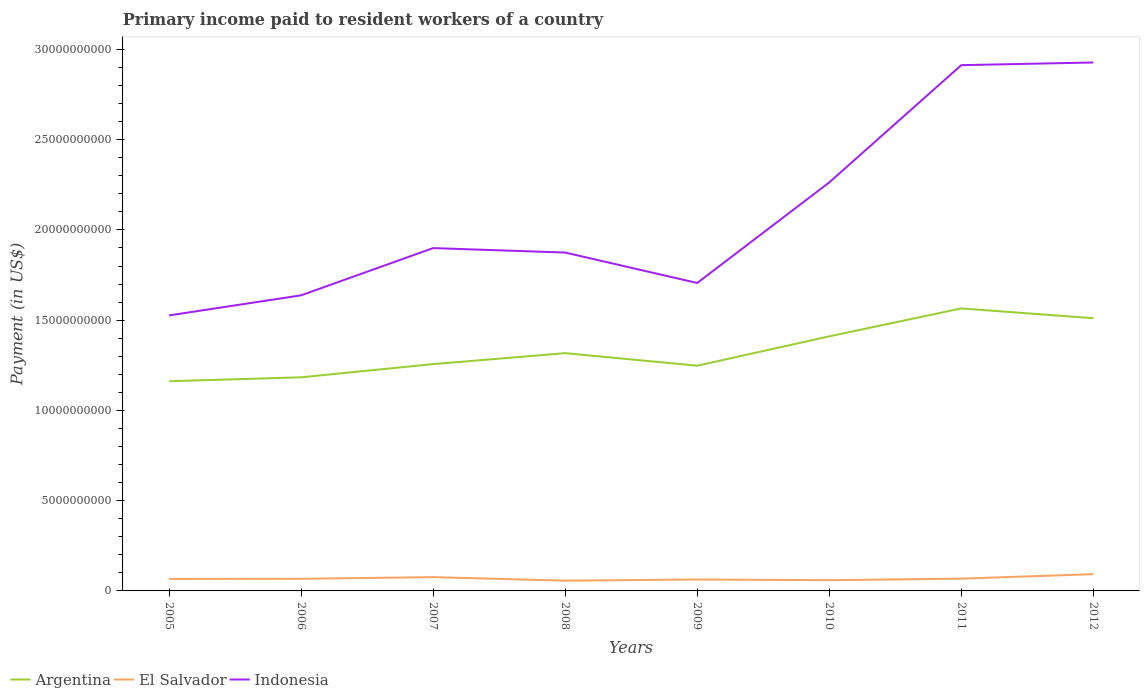How many different coloured lines are there?
Provide a succinct answer. 3. Does the line corresponding to El Salvador intersect with the line corresponding to Indonesia?
Your answer should be compact. No. Is the number of lines equal to the number of legend labels?
Your answer should be very brief. Yes. Across all years, what is the maximum amount paid to workers in El Salvador?
Your answer should be very brief. 5.68e+08. What is the total amount paid to workers in Indonesia in the graph?
Provide a succinct answer. -1.39e+1. What is the difference between the highest and the second highest amount paid to workers in Argentina?
Your answer should be compact. 4.03e+09. What is the difference between the highest and the lowest amount paid to workers in Argentina?
Provide a short and direct response. 3. How many lines are there?
Keep it short and to the point. 3. How many years are there in the graph?
Offer a terse response. 8. What is the difference between two consecutive major ticks on the Y-axis?
Make the answer very short. 5.00e+09. Are the values on the major ticks of Y-axis written in scientific E-notation?
Your answer should be compact. No. Does the graph contain grids?
Your response must be concise. No. Where does the legend appear in the graph?
Give a very brief answer. Bottom left. What is the title of the graph?
Provide a short and direct response. Primary income paid to resident workers of a country. What is the label or title of the Y-axis?
Give a very brief answer. Payment (in US$). What is the Payment (in US$) of Argentina in 2005?
Make the answer very short. 1.16e+1. What is the Payment (in US$) in El Salvador in 2005?
Your answer should be very brief. 6.65e+08. What is the Payment (in US$) of Indonesia in 2005?
Ensure brevity in your answer.  1.53e+1. What is the Payment (in US$) in Argentina in 2006?
Provide a short and direct response. 1.18e+1. What is the Payment (in US$) of El Salvador in 2006?
Keep it short and to the point. 6.72e+08. What is the Payment (in US$) of Indonesia in 2006?
Offer a terse response. 1.64e+1. What is the Payment (in US$) in Argentina in 2007?
Keep it short and to the point. 1.26e+1. What is the Payment (in US$) in El Salvador in 2007?
Your answer should be very brief. 7.64e+08. What is the Payment (in US$) in Indonesia in 2007?
Your answer should be very brief. 1.90e+1. What is the Payment (in US$) in Argentina in 2008?
Your response must be concise. 1.32e+1. What is the Payment (in US$) in El Salvador in 2008?
Your response must be concise. 5.68e+08. What is the Payment (in US$) in Indonesia in 2008?
Offer a terse response. 1.87e+1. What is the Payment (in US$) of Argentina in 2009?
Offer a very short reply. 1.25e+1. What is the Payment (in US$) of El Salvador in 2009?
Give a very brief answer. 6.33e+08. What is the Payment (in US$) of Indonesia in 2009?
Your response must be concise. 1.71e+1. What is the Payment (in US$) in Argentina in 2010?
Your answer should be compact. 1.41e+1. What is the Payment (in US$) in El Salvador in 2010?
Provide a short and direct response. 5.95e+08. What is the Payment (in US$) in Indonesia in 2010?
Offer a terse response. 2.26e+1. What is the Payment (in US$) in Argentina in 2011?
Your answer should be compact. 1.57e+1. What is the Payment (in US$) of El Salvador in 2011?
Make the answer very short. 6.80e+08. What is the Payment (in US$) in Indonesia in 2011?
Provide a succinct answer. 2.91e+1. What is the Payment (in US$) of Argentina in 2012?
Offer a terse response. 1.51e+1. What is the Payment (in US$) in El Salvador in 2012?
Your answer should be very brief. 9.29e+08. What is the Payment (in US$) in Indonesia in 2012?
Make the answer very short. 2.93e+1. Across all years, what is the maximum Payment (in US$) of Argentina?
Give a very brief answer. 1.57e+1. Across all years, what is the maximum Payment (in US$) in El Salvador?
Offer a very short reply. 9.29e+08. Across all years, what is the maximum Payment (in US$) in Indonesia?
Your answer should be compact. 2.93e+1. Across all years, what is the minimum Payment (in US$) in Argentina?
Your response must be concise. 1.16e+1. Across all years, what is the minimum Payment (in US$) in El Salvador?
Your answer should be compact. 5.68e+08. Across all years, what is the minimum Payment (in US$) in Indonesia?
Give a very brief answer. 1.53e+1. What is the total Payment (in US$) in Argentina in the graph?
Provide a succinct answer. 1.07e+11. What is the total Payment (in US$) of El Salvador in the graph?
Your answer should be compact. 5.51e+09. What is the total Payment (in US$) in Indonesia in the graph?
Offer a terse response. 1.67e+11. What is the difference between the Payment (in US$) of Argentina in 2005 and that in 2006?
Offer a very short reply. -2.18e+08. What is the difference between the Payment (in US$) in El Salvador in 2005 and that in 2006?
Give a very brief answer. -6.92e+06. What is the difference between the Payment (in US$) in Indonesia in 2005 and that in 2006?
Provide a short and direct response. -1.11e+09. What is the difference between the Payment (in US$) in Argentina in 2005 and that in 2007?
Keep it short and to the point. -9.50e+08. What is the difference between the Payment (in US$) in El Salvador in 2005 and that in 2007?
Offer a very short reply. -9.93e+07. What is the difference between the Payment (in US$) of Indonesia in 2005 and that in 2007?
Your answer should be compact. -3.73e+09. What is the difference between the Payment (in US$) in Argentina in 2005 and that in 2008?
Provide a short and direct response. -1.56e+09. What is the difference between the Payment (in US$) of El Salvador in 2005 and that in 2008?
Provide a succinct answer. 9.67e+07. What is the difference between the Payment (in US$) in Indonesia in 2005 and that in 2008?
Give a very brief answer. -3.48e+09. What is the difference between the Payment (in US$) in Argentina in 2005 and that in 2009?
Provide a succinct answer. -8.62e+08. What is the difference between the Payment (in US$) in El Salvador in 2005 and that in 2009?
Provide a short and direct response. 3.21e+07. What is the difference between the Payment (in US$) of Indonesia in 2005 and that in 2009?
Offer a very short reply. -1.80e+09. What is the difference between the Payment (in US$) of Argentina in 2005 and that in 2010?
Give a very brief answer. -2.49e+09. What is the difference between the Payment (in US$) in El Salvador in 2005 and that in 2010?
Provide a short and direct response. 7.03e+07. What is the difference between the Payment (in US$) in Indonesia in 2005 and that in 2010?
Ensure brevity in your answer.  -7.37e+09. What is the difference between the Payment (in US$) in Argentina in 2005 and that in 2011?
Ensure brevity in your answer.  -4.03e+09. What is the difference between the Payment (in US$) of El Salvador in 2005 and that in 2011?
Give a very brief answer. -1.49e+07. What is the difference between the Payment (in US$) in Indonesia in 2005 and that in 2011?
Make the answer very short. -1.39e+1. What is the difference between the Payment (in US$) in Argentina in 2005 and that in 2012?
Offer a terse response. -3.49e+09. What is the difference between the Payment (in US$) in El Salvador in 2005 and that in 2012?
Your answer should be compact. -2.64e+08. What is the difference between the Payment (in US$) in Indonesia in 2005 and that in 2012?
Offer a terse response. -1.40e+1. What is the difference between the Payment (in US$) of Argentina in 2006 and that in 2007?
Make the answer very short. -7.31e+08. What is the difference between the Payment (in US$) in El Salvador in 2006 and that in 2007?
Keep it short and to the point. -9.24e+07. What is the difference between the Payment (in US$) in Indonesia in 2006 and that in 2007?
Your answer should be very brief. -2.62e+09. What is the difference between the Payment (in US$) in Argentina in 2006 and that in 2008?
Ensure brevity in your answer.  -1.34e+09. What is the difference between the Payment (in US$) in El Salvador in 2006 and that in 2008?
Make the answer very short. 1.04e+08. What is the difference between the Payment (in US$) in Indonesia in 2006 and that in 2008?
Keep it short and to the point. -2.37e+09. What is the difference between the Payment (in US$) of Argentina in 2006 and that in 2009?
Provide a succinct answer. -6.43e+08. What is the difference between the Payment (in US$) in El Salvador in 2006 and that in 2009?
Ensure brevity in your answer.  3.90e+07. What is the difference between the Payment (in US$) of Indonesia in 2006 and that in 2009?
Offer a terse response. -6.84e+08. What is the difference between the Payment (in US$) in Argentina in 2006 and that in 2010?
Your response must be concise. -2.27e+09. What is the difference between the Payment (in US$) of El Salvador in 2006 and that in 2010?
Ensure brevity in your answer.  7.72e+07. What is the difference between the Payment (in US$) in Indonesia in 2006 and that in 2010?
Make the answer very short. -6.26e+09. What is the difference between the Payment (in US$) in Argentina in 2006 and that in 2011?
Provide a succinct answer. -3.82e+09. What is the difference between the Payment (in US$) in El Salvador in 2006 and that in 2011?
Your response must be concise. -8.01e+06. What is the difference between the Payment (in US$) in Indonesia in 2006 and that in 2011?
Offer a very short reply. -1.28e+1. What is the difference between the Payment (in US$) in Argentina in 2006 and that in 2012?
Ensure brevity in your answer.  -3.27e+09. What is the difference between the Payment (in US$) of El Salvador in 2006 and that in 2012?
Offer a very short reply. -2.57e+08. What is the difference between the Payment (in US$) in Indonesia in 2006 and that in 2012?
Make the answer very short. -1.29e+1. What is the difference between the Payment (in US$) in Argentina in 2007 and that in 2008?
Make the answer very short. -6.06e+08. What is the difference between the Payment (in US$) in El Salvador in 2007 and that in 2008?
Offer a very short reply. 1.96e+08. What is the difference between the Payment (in US$) of Indonesia in 2007 and that in 2008?
Your response must be concise. 2.47e+08. What is the difference between the Payment (in US$) of Argentina in 2007 and that in 2009?
Provide a succinct answer. 8.81e+07. What is the difference between the Payment (in US$) in El Salvador in 2007 and that in 2009?
Your answer should be very brief. 1.31e+08. What is the difference between the Payment (in US$) in Indonesia in 2007 and that in 2009?
Offer a terse response. 1.93e+09. What is the difference between the Payment (in US$) in Argentina in 2007 and that in 2010?
Your answer should be very brief. -1.54e+09. What is the difference between the Payment (in US$) in El Salvador in 2007 and that in 2010?
Provide a succinct answer. 1.70e+08. What is the difference between the Payment (in US$) in Indonesia in 2007 and that in 2010?
Your answer should be compact. -3.64e+09. What is the difference between the Payment (in US$) in Argentina in 2007 and that in 2011?
Keep it short and to the point. -3.08e+09. What is the difference between the Payment (in US$) of El Salvador in 2007 and that in 2011?
Give a very brief answer. 8.43e+07. What is the difference between the Payment (in US$) of Indonesia in 2007 and that in 2011?
Make the answer very short. -1.01e+1. What is the difference between the Payment (in US$) in Argentina in 2007 and that in 2012?
Give a very brief answer. -2.54e+09. What is the difference between the Payment (in US$) in El Salvador in 2007 and that in 2012?
Your response must be concise. -1.65e+08. What is the difference between the Payment (in US$) in Indonesia in 2007 and that in 2012?
Offer a very short reply. -1.03e+1. What is the difference between the Payment (in US$) in Argentina in 2008 and that in 2009?
Make the answer very short. 6.94e+08. What is the difference between the Payment (in US$) of El Salvador in 2008 and that in 2009?
Offer a terse response. -6.46e+07. What is the difference between the Payment (in US$) in Indonesia in 2008 and that in 2009?
Your answer should be compact. 1.69e+09. What is the difference between the Payment (in US$) of Argentina in 2008 and that in 2010?
Provide a short and direct response. -9.32e+08. What is the difference between the Payment (in US$) in El Salvador in 2008 and that in 2010?
Your answer should be very brief. -2.64e+07. What is the difference between the Payment (in US$) of Indonesia in 2008 and that in 2010?
Offer a very short reply. -3.88e+09. What is the difference between the Payment (in US$) of Argentina in 2008 and that in 2011?
Give a very brief answer. -2.48e+09. What is the difference between the Payment (in US$) in El Salvador in 2008 and that in 2011?
Your answer should be very brief. -1.12e+08. What is the difference between the Payment (in US$) in Indonesia in 2008 and that in 2011?
Your response must be concise. -1.04e+1. What is the difference between the Payment (in US$) of Argentina in 2008 and that in 2012?
Provide a short and direct response. -1.94e+09. What is the difference between the Payment (in US$) in El Salvador in 2008 and that in 2012?
Your response must be concise. -3.61e+08. What is the difference between the Payment (in US$) of Indonesia in 2008 and that in 2012?
Give a very brief answer. -1.05e+1. What is the difference between the Payment (in US$) of Argentina in 2009 and that in 2010?
Make the answer very short. -1.63e+09. What is the difference between the Payment (in US$) in El Salvador in 2009 and that in 2010?
Provide a short and direct response. 3.82e+07. What is the difference between the Payment (in US$) in Indonesia in 2009 and that in 2010?
Your answer should be compact. -5.57e+09. What is the difference between the Payment (in US$) in Argentina in 2009 and that in 2011?
Make the answer very short. -3.17e+09. What is the difference between the Payment (in US$) of El Salvador in 2009 and that in 2011?
Make the answer very short. -4.70e+07. What is the difference between the Payment (in US$) in Indonesia in 2009 and that in 2011?
Ensure brevity in your answer.  -1.21e+1. What is the difference between the Payment (in US$) of Argentina in 2009 and that in 2012?
Provide a short and direct response. -2.63e+09. What is the difference between the Payment (in US$) in El Salvador in 2009 and that in 2012?
Give a very brief answer. -2.96e+08. What is the difference between the Payment (in US$) in Indonesia in 2009 and that in 2012?
Your answer should be compact. -1.22e+1. What is the difference between the Payment (in US$) of Argentina in 2010 and that in 2011?
Offer a terse response. -1.55e+09. What is the difference between the Payment (in US$) of El Salvador in 2010 and that in 2011?
Offer a very short reply. -8.52e+07. What is the difference between the Payment (in US$) of Indonesia in 2010 and that in 2011?
Offer a very short reply. -6.50e+09. What is the difference between the Payment (in US$) of Argentina in 2010 and that in 2012?
Keep it short and to the point. -1.01e+09. What is the difference between the Payment (in US$) in El Salvador in 2010 and that in 2012?
Offer a terse response. -3.34e+08. What is the difference between the Payment (in US$) of Indonesia in 2010 and that in 2012?
Offer a very short reply. -6.65e+09. What is the difference between the Payment (in US$) in Argentina in 2011 and that in 2012?
Offer a very short reply. 5.42e+08. What is the difference between the Payment (in US$) in El Salvador in 2011 and that in 2012?
Your answer should be compact. -2.49e+08. What is the difference between the Payment (in US$) in Indonesia in 2011 and that in 2012?
Your answer should be compact. -1.49e+08. What is the difference between the Payment (in US$) in Argentina in 2005 and the Payment (in US$) in El Salvador in 2006?
Your answer should be very brief. 1.09e+1. What is the difference between the Payment (in US$) in Argentina in 2005 and the Payment (in US$) in Indonesia in 2006?
Your response must be concise. -4.76e+09. What is the difference between the Payment (in US$) in El Salvador in 2005 and the Payment (in US$) in Indonesia in 2006?
Keep it short and to the point. -1.57e+1. What is the difference between the Payment (in US$) of Argentina in 2005 and the Payment (in US$) of El Salvador in 2007?
Keep it short and to the point. 1.09e+1. What is the difference between the Payment (in US$) in Argentina in 2005 and the Payment (in US$) in Indonesia in 2007?
Provide a succinct answer. -7.38e+09. What is the difference between the Payment (in US$) in El Salvador in 2005 and the Payment (in US$) in Indonesia in 2007?
Keep it short and to the point. -1.83e+1. What is the difference between the Payment (in US$) of Argentina in 2005 and the Payment (in US$) of El Salvador in 2008?
Provide a short and direct response. 1.10e+1. What is the difference between the Payment (in US$) in Argentina in 2005 and the Payment (in US$) in Indonesia in 2008?
Give a very brief answer. -7.13e+09. What is the difference between the Payment (in US$) of El Salvador in 2005 and the Payment (in US$) of Indonesia in 2008?
Provide a succinct answer. -1.81e+1. What is the difference between the Payment (in US$) of Argentina in 2005 and the Payment (in US$) of El Salvador in 2009?
Provide a succinct answer. 1.10e+1. What is the difference between the Payment (in US$) of Argentina in 2005 and the Payment (in US$) of Indonesia in 2009?
Offer a very short reply. -5.44e+09. What is the difference between the Payment (in US$) in El Salvador in 2005 and the Payment (in US$) in Indonesia in 2009?
Provide a short and direct response. -1.64e+1. What is the difference between the Payment (in US$) of Argentina in 2005 and the Payment (in US$) of El Salvador in 2010?
Give a very brief answer. 1.10e+1. What is the difference between the Payment (in US$) in Argentina in 2005 and the Payment (in US$) in Indonesia in 2010?
Your answer should be compact. -1.10e+1. What is the difference between the Payment (in US$) of El Salvador in 2005 and the Payment (in US$) of Indonesia in 2010?
Give a very brief answer. -2.20e+1. What is the difference between the Payment (in US$) in Argentina in 2005 and the Payment (in US$) in El Salvador in 2011?
Provide a short and direct response. 1.09e+1. What is the difference between the Payment (in US$) of Argentina in 2005 and the Payment (in US$) of Indonesia in 2011?
Ensure brevity in your answer.  -1.75e+1. What is the difference between the Payment (in US$) in El Salvador in 2005 and the Payment (in US$) in Indonesia in 2011?
Provide a succinct answer. -2.85e+1. What is the difference between the Payment (in US$) of Argentina in 2005 and the Payment (in US$) of El Salvador in 2012?
Give a very brief answer. 1.07e+1. What is the difference between the Payment (in US$) of Argentina in 2005 and the Payment (in US$) of Indonesia in 2012?
Offer a very short reply. -1.77e+1. What is the difference between the Payment (in US$) in El Salvador in 2005 and the Payment (in US$) in Indonesia in 2012?
Provide a succinct answer. -2.86e+1. What is the difference between the Payment (in US$) in Argentina in 2006 and the Payment (in US$) in El Salvador in 2007?
Offer a terse response. 1.11e+1. What is the difference between the Payment (in US$) in Argentina in 2006 and the Payment (in US$) in Indonesia in 2007?
Offer a terse response. -7.16e+09. What is the difference between the Payment (in US$) of El Salvador in 2006 and the Payment (in US$) of Indonesia in 2007?
Your answer should be very brief. -1.83e+1. What is the difference between the Payment (in US$) of Argentina in 2006 and the Payment (in US$) of El Salvador in 2008?
Give a very brief answer. 1.13e+1. What is the difference between the Payment (in US$) in Argentina in 2006 and the Payment (in US$) in Indonesia in 2008?
Provide a short and direct response. -6.91e+09. What is the difference between the Payment (in US$) of El Salvador in 2006 and the Payment (in US$) of Indonesia in 2008?
Keep it short and to the point. -1.81e+1. What is the difference between the Payment (in US$) of Argentina in 2006 and the Payment (in US$) of El Salvador in 2009?
Your answer should be compact. 1.12e+1. What is the difference between the Payment (in US$) in Argentina in 2006 and the Payment (in US$) in Indonesia in 2009?
Ensure brevity in your answer.  -5.23e+09. What is the difference between the Payment (in US$) in El Salvador in 2006 and the Payment (in US$) in Indonesia in 2009?
Offer a terse response. -1.64e+1. What is the difference between the Payment (in US$) in Argentina in 2006 and the Payment (in US$) in El Salvador in 2010?
Provide a short and direct response. 1.12e+1. What is the difference between the Payment (in US$) of Argentina in 2006 and the Payment (in US$) of Indonesia in 2010?
Offer a very short reply. -1.08e+1. What is the difference between the Payment (in US$) in El Salvador in 2006 and the Payment (in US$) in Indonesia in 2010?
Give a very brief answer. -2.20e+1. What is the difference between the Payment (in US$) of Argentina in 2006 and the Payment (in US$) of El Salvador in 2011?
Your answer should be compact. 1.12e+1. What is the difference between the Payment (in US$) in Argentina in 2006 and the Payment (in US$) in Indonesia in 2011?
Provide a short and direct response. -1.73e+1. What is the difference between the Payment (in US$) in El Salvador in 2006 and the Payment (in US$) in Indonesia in 2011?
Offer a terse response. -2.85e+1. What is the difference between the Payment (in US$) of Argentina in 2006 and the Payment (in US$) of El Salvador in 2012?
Offer a terse response. 1.09e+1. What is the difference between the Payment (in US$) in Argentina in 2006 and the Payment (in US$) in Indonesia in 2012?
Your answer should be compact. -1.74e+1. What is the difference between the Payment (in US$) in El Salvador in 2006 and the Payment (in US$) in Indonesia in 2012?
Offer a terse response. -2.86e+1. What is the difference between the Payment (in US$) of Argentina in 2007 and the Payment (in US$) of El Salvador in 2008?
Keep it short and to the point. 1.20e+1. What is the difference between the Payment (in US$) of Argentina in 2007 and the Payment (in US$) of Indonesia in 2008?
Provide a succinct answer. -6.18e+09. What is the difference between the Payment (in US$) in El Salvador in 2007 and the Payment (in US$) in Indonesia in 2008?
Provide a succinct answer. -1.80e+1. What is the difference between the Payment (in US$) of Argentina in 2007 and the Payment (in US$) of El Salvador in 2009?
Make the answer very short. 1.19e+1. What is the difference between the Payment (in US$) in Argentina in 2007 and the Payment (in US$) in Indonesia in 2009?
Your response must be concise. -4.49e+09. What is the difference between the Payment (in US$) in El Salvador in 2007 and the Payment (in US$) in Indonesia in 2009?
Your answer should be compact. -1.63e+1. What is the difference between the Payment (in US$) in Argentina in 2007 and the Payment (in US$) in El Salvador in 2010?
Your response must be concise. 1.20e+1. What is the difference between the Payment (in US$) in Argentina in 2007 and the Payment (in US$) in Indonesia in 2010?
Offer a terse response. -1.01e+1. What is the difference between the Payment (in US$) of El Salvador in 2007 and the Payment (in US$) of Indonesia in 2010?
Make the answer very short. -2.19e+1. What is the difference between the Payment (in US$) of Argentina in 2007 and the Payment (in US$) of El Salvador in 2011?
Your answer should be compact. 1.19e+1. What is the difference between the Payment (in US$) of Argentina in 2007 and the Payment (in US$) of Indonesia in 2011?
Your answer should be very brief. -1.66e+1. What is the difference between the Payment (in US$) in El Salvador in 2007 and the Payment (in US$) in Indonesia in 2011?
Your answer should be very brief. -2.84e+1. What is the difference between the Payment (in US$) in Argentina in 2007 and the Payment (in US$) in El Salvador in 2012?
Your answer should be very brief. 1.16e+1. What is the difference between the Payment (in US$) in Argentina in 2007 and the Payment (in US$) in Indonesia in 2012?
Your answer should be compact. -1.67e+1. What is the difference between the Payment (in US$) in El Salvador in 2007 and the Payment (in US$) in Indonesia in 2012?
Offer a very short reply. -2.85e+1. What is the difference between the Payment (in US$) of Argentina in 2008 and the Payment (in US$) of El Salvador in 2009?
Your answer should be compact. 1.25e+1. What is the difference between the Payment (in US$) of Argentina in 2008 and the Payment (in US$) of Indonesia in 2009?
Provide a short and direct response. -3.89e+09. What is the difference between the Payment (in US$) of El Salvador in 2008 and the Payment (in US$) of Indonesia in 2009?
Your response must be concise. -1.65e+1. What is the difference between the Payment (in US$) of Argentina in 2008 and the Payment (in US$) of El Salvador in 2010?
Ensure brevity in your answer.  1.26e+1. What is the difference between the Payment (in US$) in Argentina in 2008 and the Payment (in US$) in Indonesia in 2010?
Your answer should be compact. -9.46e+09. What is the difference between the Payment (in US$) in El Salvador in 2008 and the Payment (in US$) in Indonesia in 2010?
Give a very brief answer. -2.21e+1. What is the difference between the Payment (in US$) in Argentina in 2008 and the Payment (in US$) in El Salvador in 2011?
Offer a terse response. 1.25e+1. What is the difference between the Payment (in US$) in Argentina in 2008 and the Payment (in US$) in Indonesia in 2011?
Ensure brevity in your answer.  -1.60e+1. What is the difference between the Payment (in US$) in El Salvador in 2008 and the Payment (in US$) in Indonesia in 2011?
Your answer should be very brief. -2.86e+1. What is the difference between the Payment (in US$) of Argentina in 2008 and the Payment (in US$) of El Salvador in 2012?
Your response must be concise. 1.22e+1. What is the difference between the Payment (in US$) of Argentina in 2008 and the Payment (in US$) of Indonesia in 2012?
Provide a short and direct response. -1.61e+1. What is the difference between the Payment (in US$) in El Salvador in 2008 and the Payment (in US$) in Indonesia in 2012?
Keep it short and to the point. -2.87e+1. What is the difference between the Payment (in US$) in Argentina in 2009 and the Payment (in US$) in El Salvador in 2010?
Offer a very short reply. 1.19e+1. What is the difference between the Payment (in US$) of Argentina in 2009 and the Payment (in US$) of Indonesia in 2010?
Give a very brief answer. -1.02e+1. What is the difference between the Payment (in US$) of El Salvador in 2009 and the Payment (in US$) of Indonesia in 2010?
Provide a short and direct response. -2.20e+1. What is the difference between the Payment (in US$) of Argentina in 2009 and the Payment (in US$) of El Salvador in 2011?
Ensure brevity in your answer.  1.18e+1. What is the difference between the Payment (in US$) of Argentina in 2009 and the Payment (in US$) of Indonesia in 2011?
Your answer should be compact. -1.66e+1. What is the difference between the Payment (in US$) of El Salvador in 2009 and the Payment (in US$) of Indonesia in 2011?
Keep it short and to the point. -2.85e+1. What is the difference between the Payment (in US$) of Argentina in 2009 and the Payment (in US$) of El Salvador in 2012?
Your answer should be very brief. 1.15e+1. What is the difference between the Payment (in US$) in Argentina in 2009 and the Payment (in US$) in Indonesia in 2012?
Offer a very short reply. -1.68e+1. What is the difference between the Payment (in US$) in El Salvador in 2009 and the Payment (in US$) in Indonesia in 2012?
Keep it short and to the point. -2.86e+1. What is the difference between the Payment (in US$) in Argentina in 2010 and the Payment (in US$) in El Salvador in 2011?
Make the answer very short. 1.34e+1. What is the difference between the Payment (in US$) in Argentina in 2010 and the Payment (in US$) in Indonesia in 2011?
Your answer should be compact. -1.50e+1. What is the difference between the Payment (in US$) of El Salvador in 2010 and the Payment (in US$) of Indonesia in 2011?
Keep it short and to the point. -2.85e+1. What is the difference between the Payment (in US$) of Argentina in 2010 and the Payment (in US$) of El Salvador in 2012?
Offer a very short reply. 1.32e+1. What is the difference between the Payment (in US$) in Argentina in 2010 and the Payment (in US$) in Indonesia in 2012?
Provide a succinct answer. -1.52e+1. What is the difference between the Payment (in US$) of El Salvador in 2010 and the Payment (in US$) of Indonesia in 2012?
Keep it short and to the point. -2.87e+1. What is the difference between the Payment (in US$) of Argentina in 2011 and the Payment (in US$) of El Salvador in 2012?
Your response must be concise. 1.47e+1. What is the difference between the Payment (in US$) in Argentina in 2011 and the Payment (in US$) in Indonesia in 2012?
Provide a succinct answer. -1.36e+1. What is the difference between the Payment (in US$) in El Salvador in 2011 and the Payment (in US$) in Indonesia in 2012?
Your answer should be compact. -2.86e+1. What is the average Payment (in US$) of Argentina per year?
Offer a very short reply. 1.33e+1. What is the average Payment (in US$) in El Salvador per year?
Your answer should be compact. 6.88e+08. What is the average Payment (in US$) in Indonesia per year?
Offer a terse response. 2.09e+1. In the year 2005, what is the difference between the Payment (in US$) of Argentina and Payment (in US$) of El Salvador?
Give a very brief answer. 1.10e+1. In the year 2005, what is the difference between the Payment (in US$) of Argentina and Payment (in US$) of Indonesia?
Offer a very short reply. -3.65e+09. In the year 2005, what is the difference between the Payment (in US$) of El Salvador and Payment (in US$) of Indonesia?
Offer a terse response. -1.46e+1. In the year 2006, what is the difference between the Payment (in US$) of Argentina and Payment (in US$) of El Salvador?
Keep it short and to the point. 1.12e+1. In the year 2006, what is the difference between the Payment (in US$) of Argentina and Payment (in US$) of Indonesia?
Provide a succinct answer. -4.54e+09. In the year 2006, what is the difference between the Payment (in US$) of El Salvador and Payment (in US$) of Indonesia?
Provide a succinct answer. -1.57e+1. In the year 2007, what is the difference between the Payment (in US$) of Argentina and Payment (in US$) of El Salvador?
Ensure brevity in your answer.  1.18e+1. In the year 2007, what is the difference between the Payment (in US$) in Argentina and Payment (in US$) in Indonesia?
Provide a succinct answer. -6.43e+09. In the year 2007, what is the difference between the Payment (in US$) in El Salvador and Payment (in US$) in Indonesia?
Your response must be concise. -1.82e+1. In the year 2008, what is the difference between the Payment (in US$) of Argentina and Payment (in US$) of El Salvador?
Provide a short and direct response. 1.26e+1. In the year 2008, what is the difference between the Payment (in US$) in Argentina and Payment (in US$) in Indonesia?
Your answer should be compact. -5.57e+09. In the year 2008, what is the difference between the Payment (in US$) in El Salvador and Payment (in US$) in Indonesia?
Your answer should be compact. -1.82e+1. In the year 2009, what is the difference between the Payment (in US$) of Argentina and Payment (in US$) of El Salvador?
Ensure brevity in your answer.  1.18e+1. In the year 2009, what is the difference between the Payment (in US$) of Argentina and Payment (in US$) of Indonesia?
Offer a terse response. -4.58e+09. In the year 2009, what is the difference between the Payment (in US$) in El Salvador and Payment (in US$) in Indonesia?
Offer a terse response. -1.64e+1. In the year 2010, what is the difference between the Payment (in US$) of Argentina and Payment (in US$) of El Salvador?
Ensure brevity in your answer.  1.35e+1. In the year 2010, what is the difference between the Payment (in US$) in Argentina and Payment (in US$) in Indonesia?
Your answer should be very brief. -8.53e+09. In the year 2010, what is the difference between the Payment (in US$) of El Salvador and Payment (in US$) of Indonesia?
Offer a terse response. -2.20e+1. In the year 2011, what is the difference between the Payment (in US$) in Argentina and Payment (in US$) in El Salvador?
Provide a succinct answer. 1.50e+1. In the year 2011, what is the difference between the Payment (in US$) in Argentina and Payment (in US$) in Indonesia?
Provide a short and direct response. -1.35e+1. In the year 2011, what is the difference between the Payment (in US$) in El Salvador and Payment (in US$) in Indonesia?
Your answer should be compact. -2.84e+1. In the year 2012, what is the difference between the Payment (in US$) of Argentina and Payment (in US$) of El Salvador?
Your answer should be compact. 1.42e+1. In the year 2012, what is the difference between the Payment (in US$) in Argentina and Payment (in US$) in Indonesia?
Give a very brief answer. -1.42e+1. In the year 2012, what is the difference between the Payment (in US$) of El Salvador and Payment (in US$) of Indonesia?
Keep it short and to the point. -2.83e+1. What is the ratio of the Payment (in US$) in Argentina in 2005 to that in 2006?
Keep it short and to the point. 0.98. What is the ratio of the Payment (in US$) in El Salvador in 2005 to that in 2006?
Provide a succinct answer. 0.99. What is the ratio of the Payment (in US$) of Indonesia in 2005 to that in 2006?
Give a very brief answer. 0.93. What is the ratio of the Payment (in US$) in Argentina in 2005 to that in 2007?
Provide a succinct answer. 0.92. What is the ratio of the Payment (in US$) in El Salvador in 2005 to that in 2007?
Your response must be concise. 0.87. What is the ratio of the Payment (in US$) in Indonesia in 2005 to that in 2007?
Offer a terse response. 0.8. What is the ratio of the Payment (in US$) in Argentina in 2005 to that in 2008?
Give a very brief answer. 0.88. What is the ratio of the Payment (in US$) of El Salvador in 2005 to that in 2008?
Ensure brevity in your answer.  1.17. What is the ratio of the Payment (in US$) in Indonesia in 2005 to that in 2008?
Offer a terse response. 0.81. What is the ratio of the Payment (in US$) of Argentina in 2005 to that in 2009?
Give a very brief answer. 0.93. What is the ratio of the Payment (in US$) of El Salvador in 2005 to that in 2009?
Provide a succinct answer. 1.05. What is the ratio of the Payment (in US$) of Indonesia in 2005 to that in 2009?
Ensure brevity in your answer.  0.89. What is the ratio of the Payment (in US$) in Argentina in 2005 to that in 2010?
Ensure brevity in your answer.  0.82. What is the ratio of the Payment (in US$) in El Salvador in 2005 to that in 2010?
Your answer should be compact. 1.12. What is the ratio of the Payment (in US$) of Indonesia in 2005 to that in 2010?
Provide a short and direct response. 0.67. What is the ratio of the Payment (in US$) of Argentina in 2005 to that in 2011?
Give a very brief answer. 0.74. What is the ratio of the Payment (in US$) of El Salvador in 2005 to that in 2011?
Keep it short and to the point. 0.98. What is the ratio of the Payment (in US$) of Indonesia in 2005 to that in 2011?
Give a very brief answer. 0.52. What is the ratio of the Payment (in US$) of Argentina in 2005 to that in 2012?
Offer a very short reply. 0.77. What is the ratio of the Payment (in US$) of El Salvador in 2005 to that in 2012?
Ensure brevity in your answer.  0.72. What is the ratio of the Payment (in US$) in Indonesia in 2005 to that in 2012?
Provide a succinct answer. 0.52. What is the ratio of the Payment (in US$) in Argentina in 2006 to that in 2007?
Offer a terse response. 0.94. What is the ratio of the Payment (in US$) of El Salvador in 2006 to that in 2007?
Offer a terse response. 0.88. What is the ratio of the Payment (in US$) in Indonesia in 2006 to that in 2007?
Make the answer very short. 0.86. What is the ratio of the Payment (in US$) in Argentina in 2006 to that in 2008?
Keep it short and to the point. 0.9. What is the ratio of the Payment (in US$) of El Salvador in 2006 to that in 2008?
Your answer should be very brief. 1.18. What is the ratio of the Payment (in US$) in Indonesia in 2006 to that in 2008?
Your answer should be compact. 0.87. What is the ratio of the Payment (in US$) in Argentina in 2006 to that in 2009?
Your response must be concise. 0.95. What is the ratio of the Payment (in US$) of El Salvador in 2006 to that in 2009?
Provide a short and direct response. 1.06. What is the ratio of the Payment (in US$) of Indonesia in 2006 to that in 2009?
Give a very brief answer. 0.96. What is the ratio of the Payment (in US$) in Argentina in 2006 to that in 2010?
Ensure brevity in your answer.  0.84. What is the ratio of the Payment (in US$) in El Salvador in 2006 to that in 2010?
Offer a very short reply. 1.13. What is the ratio of the Payment (in US$) of Indonesia in 2006 to that in 2010?
Make the answer very short. 0.72. What is the ratio of the Payment (in US$) in Argentina in 2006 to that in 2011?
Offer a very short reply. 0.76. What is the ratio of the Payment (in US$) of El Salvador in 2006 to that in 2011?
Your answer should be very brief. 0.99. What is the ratio of the Payment (in US$) in Indonesia in 2006 to that in 2011?
Provide a succinct answer. 0.56. What is the ratio of the Payment (in US$) in Argentina in 2006 to that in 2012?
Offer a very short reply. 0.78. What is the ratio of the Payment (in US$) in El Salvador in 2006 to that in 2012?
Ensure brevity in your answer.  0.72. What is the ratio of the Payment (in US$) of Indonesia in 2006 to that in 2012?
Give a very brief answer. 0.56. What is the ratio of the Payment (in US$) of Argentina in 2007 to that in 2008?
Your answer should be very brief. 0.95. What is the ratio of the Payment (in US$) of El Salvador in 2007 to that in 2008?
Provide a short and direct response. 1.34. What is the ratio of the Payment (in US$) in Indonesia in 2007 to that in 2008?
Offer a terse response. 1.01. What is the ratio of the Payment (in US$) in Argentina in 2007 to that in 2009?
Your answer should be very brief. 1.01. What is the ratio of the Payment (in US$) in El Salvador in 2007 to that in 2009?
Offer a very short reply. 1.21. What is the ratio of the Payment (in US$) of Indonesia in 2007 to that in 2009?
Offer a very short reply. 1.11. What is the ratio of the Payment (in US$) in Argentina in 2007 to that in 2010?
Offer a very short reply. 0.89. What is the ratio of the Payment (in US$) in El Salvador in 2007 to that in 2010?
Ensure brevity in your answer.  1.29. What is the ratio of the Payment (in US$) of Indonesia in 2007 to that in 2010?
Make the answer very short. 0.84. What is the ratio of the Payment (in US$) in Argentina in 2007 to that in 2011?
Provide a short and direct response. 0.8. What is the ratio of the Payment (in US$) of El Salvador in 2007 to that in 2011?
Your response must be concise. 1.12. What is the ratio of the Payment (in US$) in Indonesia in 2007 to that in 2011?
Provide a short and direct response. 0.65. What is the ratio of the Payment (in US$) in Argentina in 2007 to that in 2012?
Your response must be concise. 0.83. What is the ratio of the Payment (in US$) of El Salvador in 2007 to that in 2012?
Your answer should be compact. 0.82. What is the ratio of the Payment (in US$) in Indonesia in 2007 to that in 2012?
Offer a very short reply. 0.65. What is the ratio of the Payment (in US$) of Argentina in 2008 to that in 2009?
Make the answer very short. 1.06. What is the ratio of the Payment (in US$) of El Salvador in 2008 to that in 2009?
Provide a short and direct response. 0.9. What is the ratio of the Payment (in US$) in Indonesia in 2008 to that in 2009?
Make the answer very short. 1.1. What is the ratio of the Payment (in US$) of Argentina in 2008 to that in 2010?
Offer a very short reply. 0.93. What is the ratio of the Payment (in US$) of El Salvador in 2008 to that in 2010?
Your response must be concise. 0.96. What is the ratio of the Payment (in US$) of Indonesia in 2008 to that in 2010?
Provide a succinct answer. 0.83. What is the ratio of the Payment (in US$) in Argentina in 2008 to that in 2011?
Keep it short and to the point. 0.84. What is the ratio of the Payment (in US$) in El Salvador in 2008 to that in 2011?
Provide a short and direct response. 0.84. What is the ratio of the Payment (in US$) of Indonesia in 2008 to that in 2011?
Offer a very short reply. 0.64. What is the ratio of the Payment (in US$) in Argentina in 2008 to that in 2012?
Keep it short and to the point. 0.87. What is the ratio of the Payment (in US$) of El Salvador in 2008 to that in 2012?
Give a very brief answer. 0.61. What is the ratio of the Payment (in US$) in Indonesia in 2008 to that in 2012?
Offer a very short reply. 0.64. What is the ratio of the Payment (in US$) of Argentina in 2009 to that in 2010?
Provide a short and direct response. 0.88. What is the ratio of the Payment (in US$) of El Salvador in 2009 to that in 2010?
Give a very brief answer. 1.06. What is the ratio of the Payment (in US$) of Indonesia in 2009 to that in 2010?
Your answer should be very brief. 0.75. What is the ratio of the Payment (in US$) in Argentina in 2009 to that in 2011?
Your answer should be compact. 0.8. What is the ratio of the Payment (in US$) of El Salvador in 2009 to that in 2011?
Keep it short and to the point. 0.93. What is the ratio of the Payment (in US$) in Indonesia in 2009 to that in 2011?
Offer a terse response. 0.59. What is the ratio of the Payment (in US$) in Argentina in 2009 to that in 2012?
Ensure brevity in your answer.  0.83. What is the ratio of the Payment (in US$) of El Salvador in 2009 to that in 2012?
Provide a short and direct response. 0.68. What is the ratio of the Payment (in US$) in Indonesia in 2009 to that in 2012?
Your response must be concise. 0.58. What is the ratio of the Payment (in US$) in Argentina in 2010 to that in 2011?
Provide a short and direct response. 0.9. What is the ratio of the Payment (in US$) in El Salvador in 2010 to that in 2011?
Your answer should be very brief. 0.87. What is the ratio of the Payment (in US$) in Indonesia in 2010 to that in 2011?
Ensure brevity in your answer.  0.78. What is the ratio of the Payment (in US$) of Argentina in 2010 to that in 2012?
Offer a very short reply. 0.93. What is the ratio of the Payment (in US$) of El Salvador in 2010 to that in 2012?
Make the answer very short. 0.64. What is the ratio of the Payment (in US$) in Indonesia in 2010 to that in 2012?
Offer a terse response. 0.77. What is the ratio of the Payment (in US$) of Argentina in 2011 to that in 2012?
Keep it short and to the point. 1.04. What is the ratio of the Payment (in US$) in El Salvador in 2011 to that in 2012?
Ensure brevity in your answer.  0.73. What is the difference between the highest and the second highest Payment (in US$) in Argentina?
Make the answer very short. 5.42e+08. What is the difference between the highest and the second highest Payment (in US$) in El Salvador?
Your answer should be very brief. 1.65e+08. What is the difference between the highest and the second highest Payment (in US$) in Indonesia?
Your answer should be very brief. 1.49e+08. What is the difference between the highest and the lowest Payment (in US$) of Argentina?
Make the answer very short. 4.03e+09. What is the difference between the highest and the lowest Payment (in US$) of El Salvador?
Your response must be concise. 3.61e+08. What is the difference between the highest and the lowest Payment (in US$) of Indonesia?
Your response must be concise. 1.40e+1. 